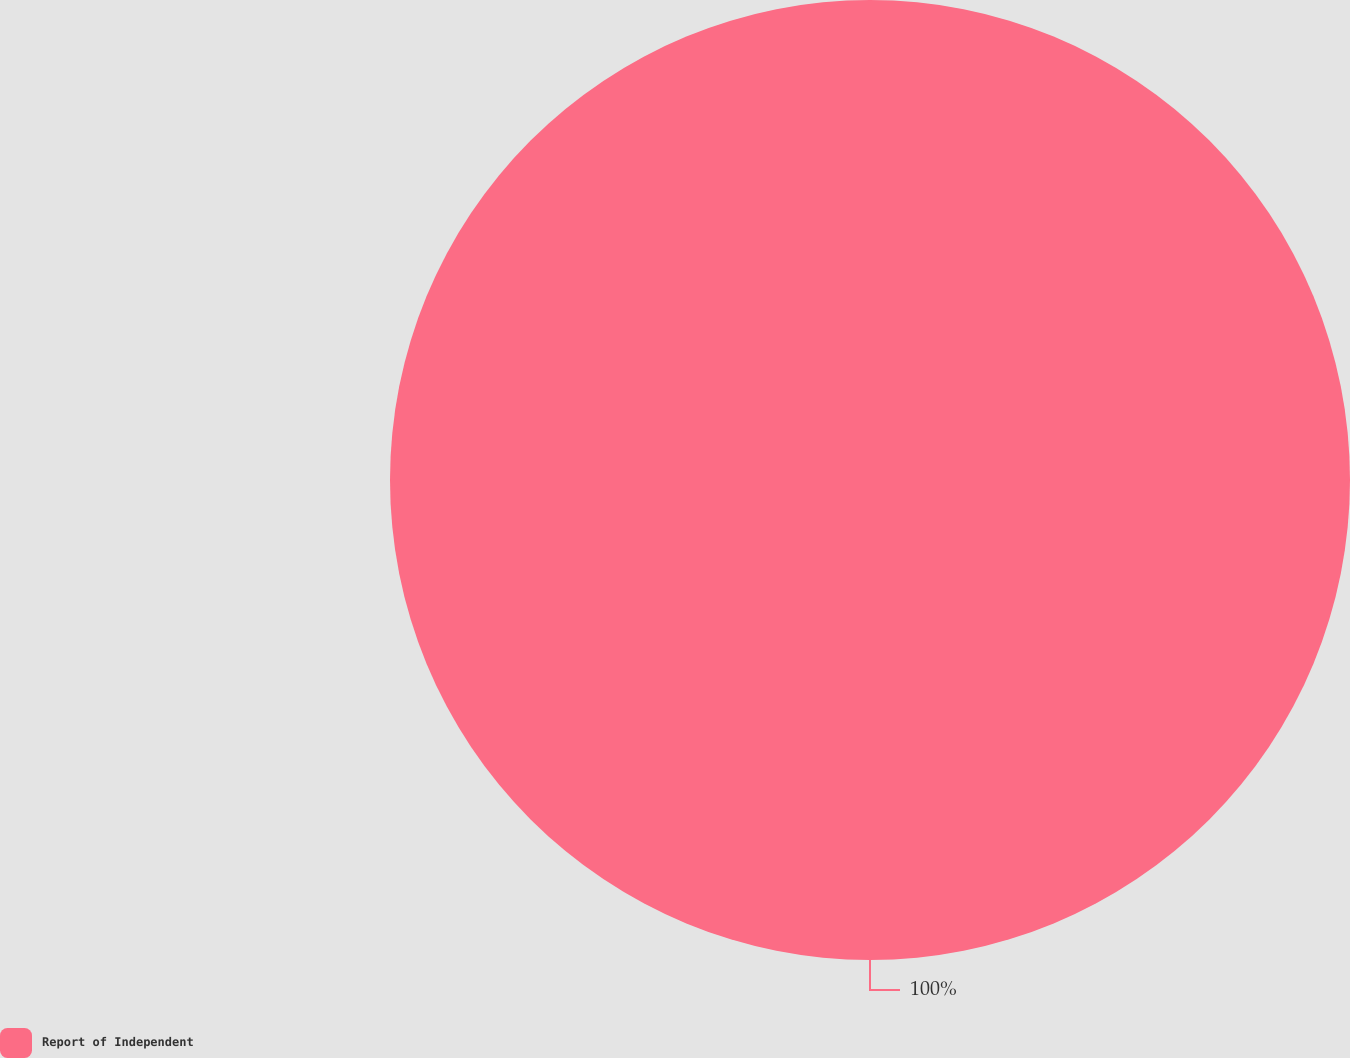Convert chart. <chart><loc_0><loc_0><loc_500><loc_500><pie_chart><fcel>Report of Independent<nl><fcel>100.0%<nl></chart> 